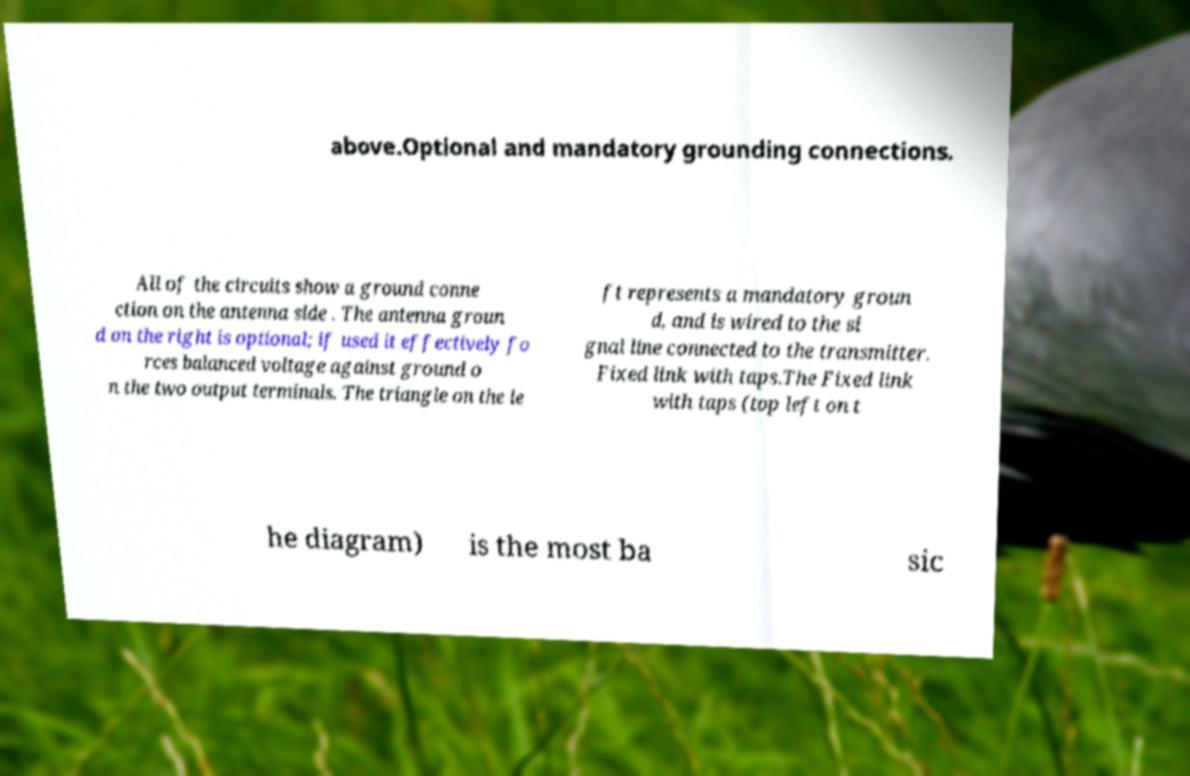Please read and relay the text visible in this image. What does it say? above.Optional and mandatory grounding connections. All of the circuits show a ground conne ction on the antenna side . The antenna groun d on the right is optional; if used it effectively fo rces balanced voltage against ground o n the two output terminals. The triangle on the le ft represents a mandatory groun d, and is wired to the si gnal line connected to the transmitter. Fixed link with taps.The Fixed link with taps (top left on t he diagram) is the most ba sic 